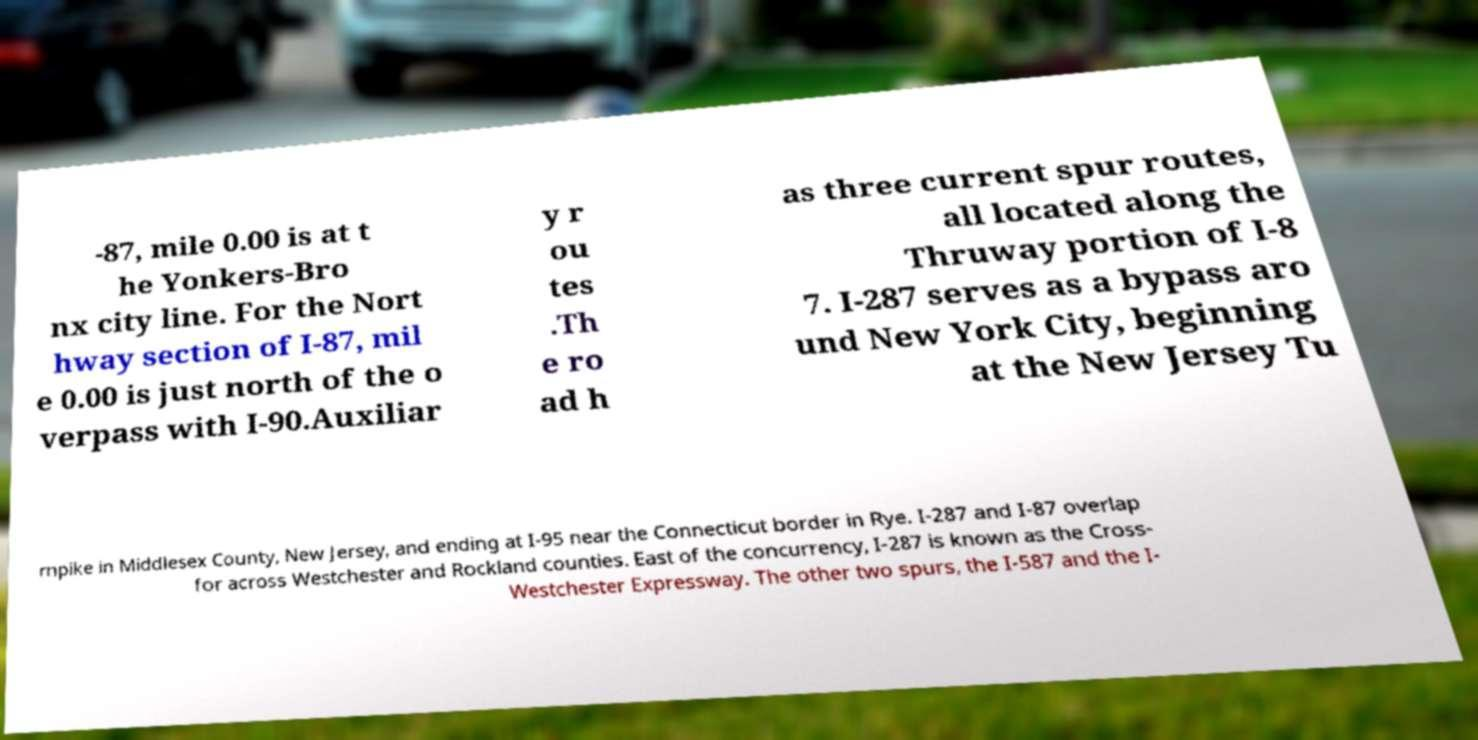Could you extract and type out the text from this image? -87, mile 0.00 is at t he Yonkers-Bro nx city line. For the Nort hway section of I-87, mil e 0.00 is just north of the o verpass with I-90.Auxiliar y r ou tes .Th e ro ad h as three current spur routes, all located along the Thruway portion of I-8 7. I-287 serves as a bypass aro und New York City, beginning at the New Jersey Tu rnpike in Middlesex County, New Jersey, and ending at I-95 near the Connecticut border in Rye. I-287 and I-87 overlap for across Westchester and Rockland counties. East of the concurrency, I-287 is known as the Cross- Westchester Expressway. The other two spurs, the I-587 and the I- 